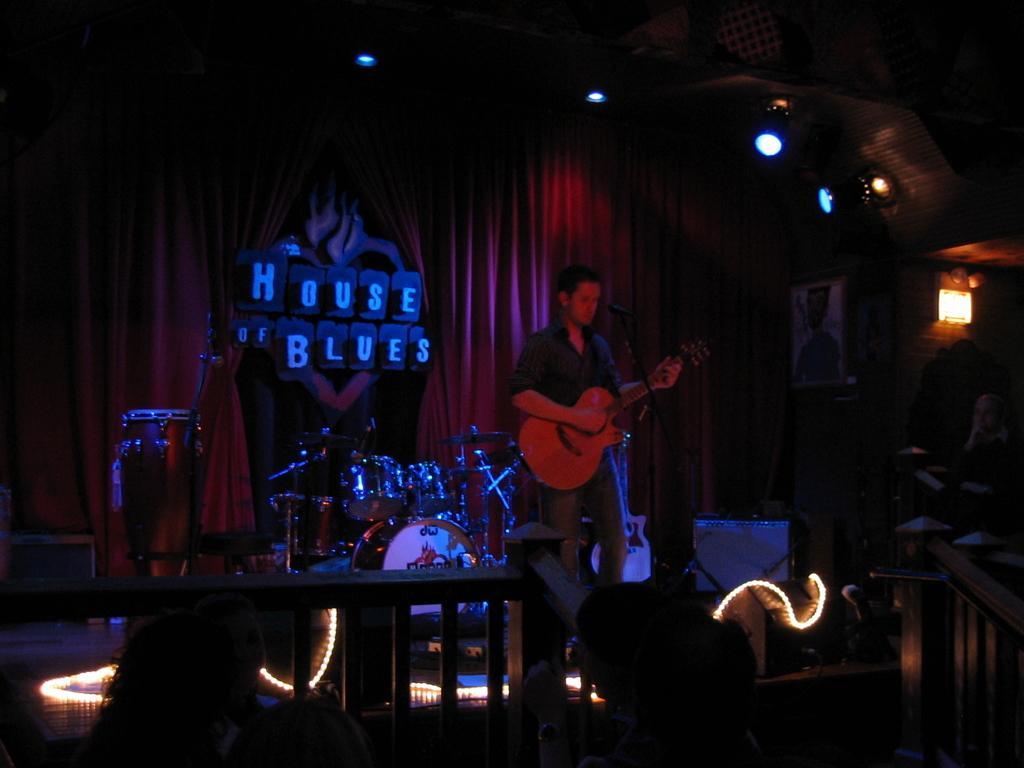Please provide a concise description of this image. This person is standing and playing a guitar in-front of mic. These are focusing lights. This is a red curtain. These are musical instruments. A picture on wall. 